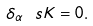<formula> <loc_0><loc_0><loc_500><loc_500>\delta _ { \alpha } \ s K = 0 .</formula> 